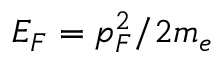<formula> <loc_0><loc_0><loc_500><loc_500>E _ { F } = p _ { F } ^ { 2 } / 2 m _ { e }</formula> 